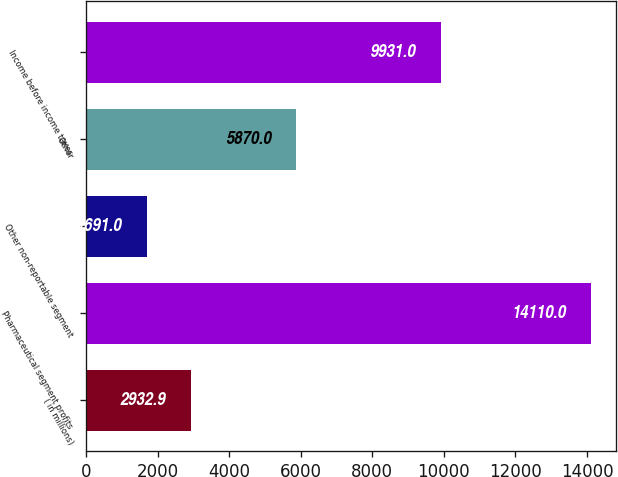<chart> <loc_0><loc_0><loc_500><loc_500><bar_chart><fcel>( in millions)<fcel>Pharmaceutical segment profits<fcel>Other non-reportable segment<fcel>Other<fcel>Income before income taxes<nl><fcel>2932.9<fcel>14110<fcel>1691<fcel>5870<fcel>9931<nl></chart> 